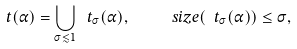<formula> <loc_0><loc_0><loc_500><loc_500>\ t ( \alpha ) = \bigcup _ { \sigma \lesssim 1 } \ t _ { \sigma } ( \alpha ) , \quad \ s i z e ( \ t _ { \sigma } ( \alpha ) ) \leq \sigma ,</formula> 